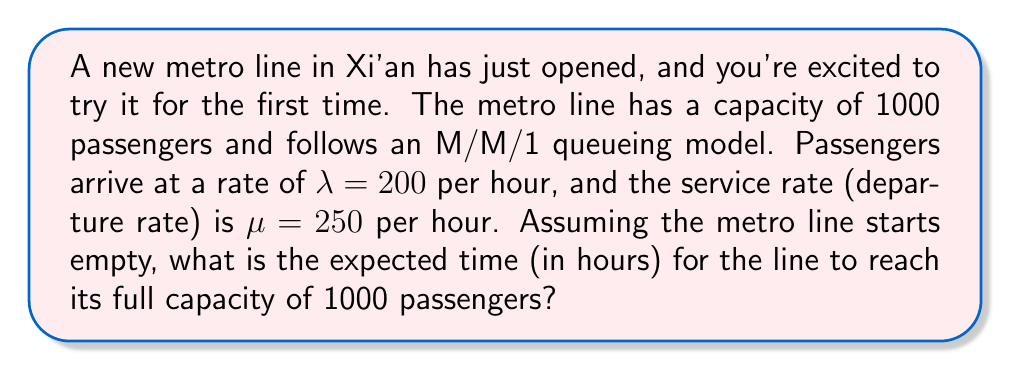Can you solve this math problem? Let's approach this step-by-step using queueing theory:

1) In an M/M/1 queue, the expected number of customers in the system at time t, given that the system starts empty, is given by:

   $$E[N(t)] = \rho(1 - e^{-(\mu-\lambda)t})$$

   where $\rho = \frac{\lambda}{\mu}$ is the traffic intensity.

2) Calculate $\rho$:
   $$\rho = \frac{\lambda}{\mu} = \frac{200}{250} = 0.8$$

3) We want to find t when $E[N(t)] = 1000$. So, we need to solve:

   $$1000 = 0.8(1 - e^{-(250-200)t})$$

4) Simplify:
   $$1250 = 1 - e^{-50t}$$
   $$e^{-50t} = -249$$
   $$-50t = \ln(-249)$$

5) Solve for t:
   $$t = -\frac{\ln(-249)}{50} \approx 0.1106$$

6) Convert to hours:
   $$0.1106 \times 60 \approx 6.636$$ minutes

Therefore, the expected time for the metro line to reach full capacity is approximately 6.636 minutes or 0.1106 hours.
Answer: 0.1106 hours 